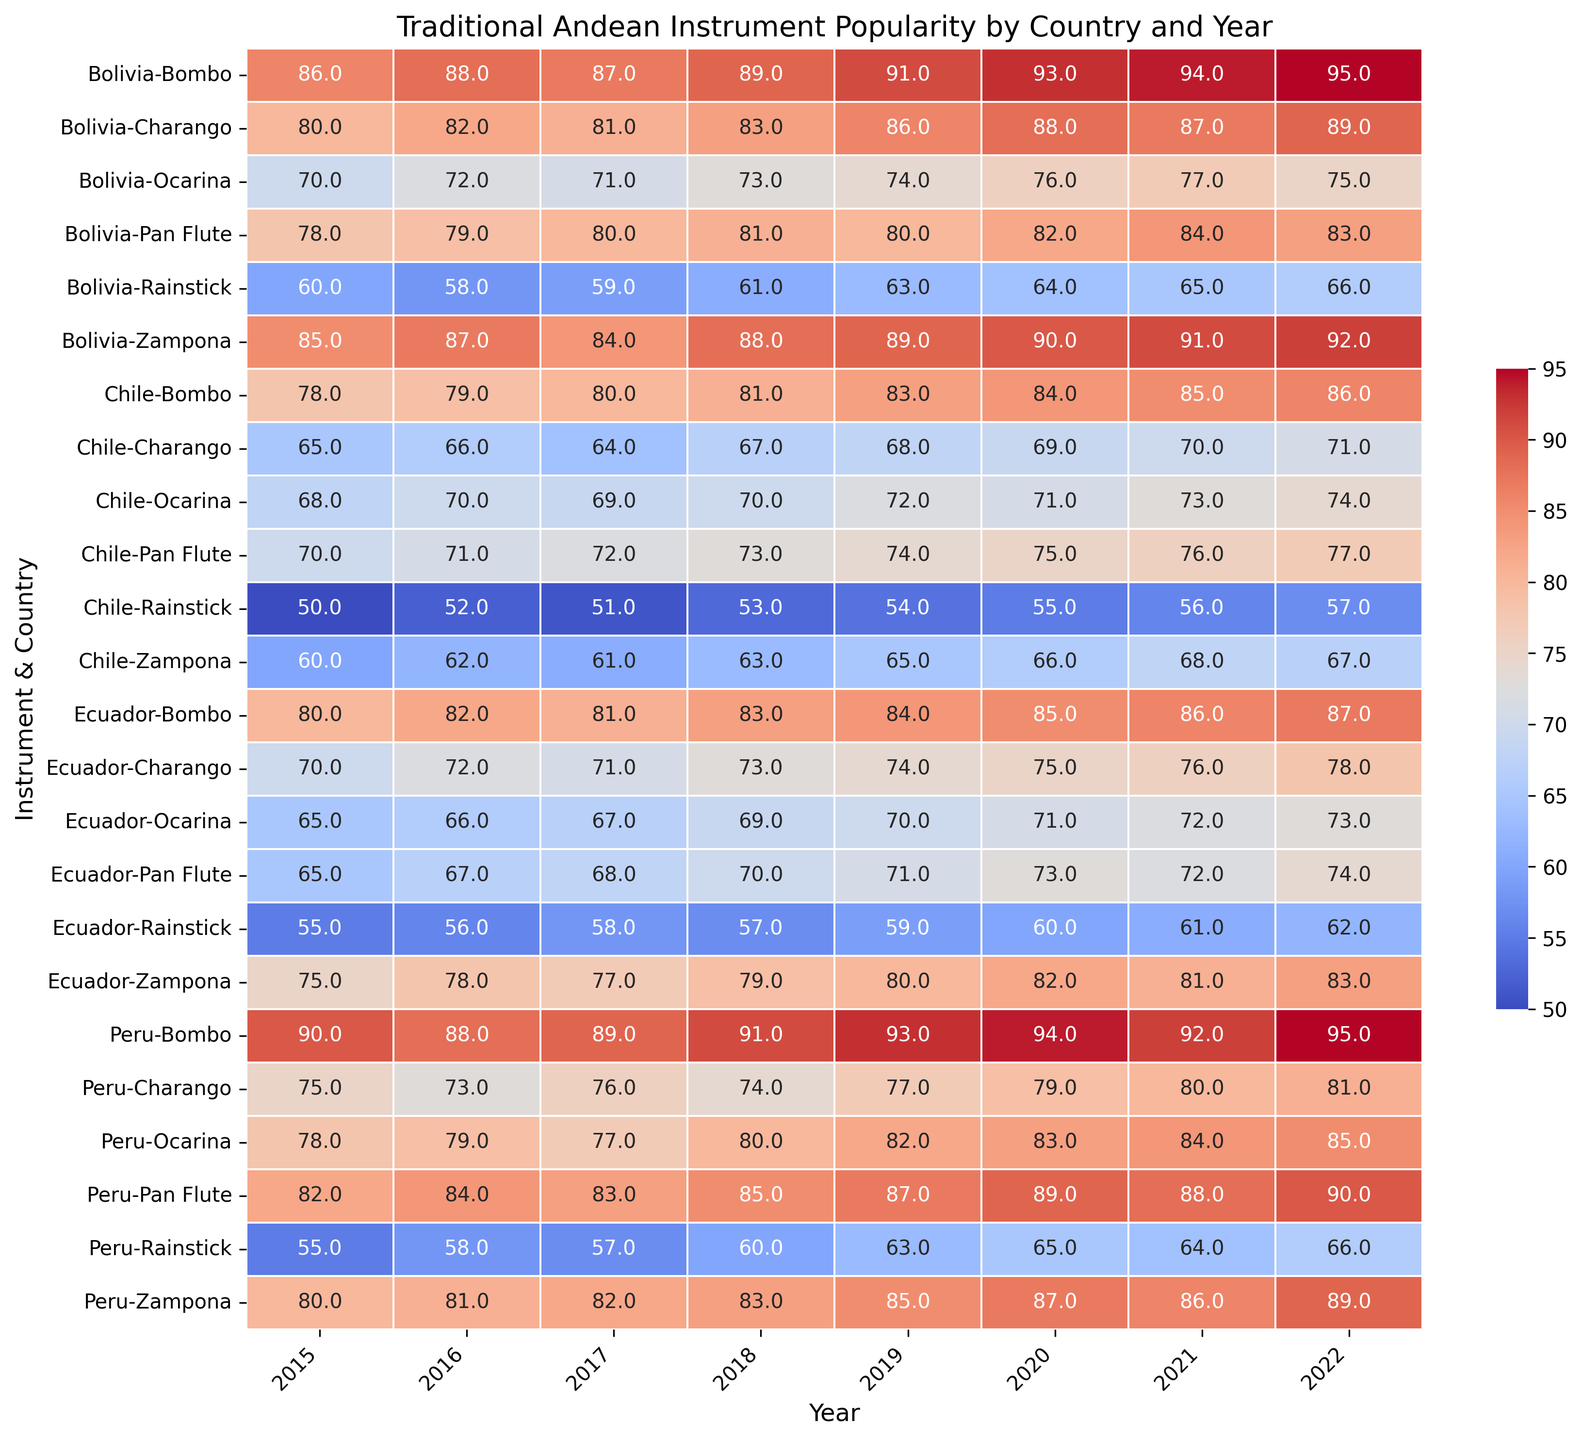What's the most popular instrument in Peru in 2022? Look at the values for each instrument in Peru for 2022 and pick the highest one. Pan Flute has the highest popularity with 90.
Answer: Pan Flute Which country had the highest popularity for the Ocarina in 2020? Compare the popularity of the Ocarina in 2020 across different countries. Peru has the highest value of 83.
Answer: Peru How did the popularity of the Charango in Bolivia change from 2015 to 2022? Check the values for the Charango in Bolivia from 2015 to 2022. The values are 80, 82, 81, 83, 86, 88, 87, 89, showing a trend of overall increase over the years with slight fluctuations.
Answer: Increased Which country shows the most consistent popularity for the Rainstick across the years? Compare the yearly popularity values for the Rainstick in each country. Bolivia’s values (60, 58, 59, 61, 63, 64, 65, 66) show smaller fluctuations compared to others.
Answer: Bolivia Which year saw the highest average popularity for all instruments combined across all countries? Calculate the average popularity per year for all instruments combined across all countries. 2022 has the highest average when you sum all values and divide by the number of data points.
Answer: 2022 Did the popularity of the Zampona in Chile increase or decrease from 2015 to 2022? Look at the popularity values of the Zampona in Chile from 2015 to 2022. The values are 60, 62, 61, 63, 65, 66, 68, 67, showing an overall increase despite a dip in 2022.
Answer: Increased What is the range of popularity for the Bombo in Ecuador from 2015 to 2022? Find the highest (87) and lowest (80) values of the Bombo in Ecuador between 2015 and 2022. The range is 87 - 80 = 7.
Answer: 7 Among the instruments, which had the most similar popularity trends in Peru and Chile from 2015 to 2022? Compare the popularity trends for each instrument between Peru and Chile from 2015 to 2022. Pan Flute shows similar increasing trends in both countries.
Answer: Pan Flute 